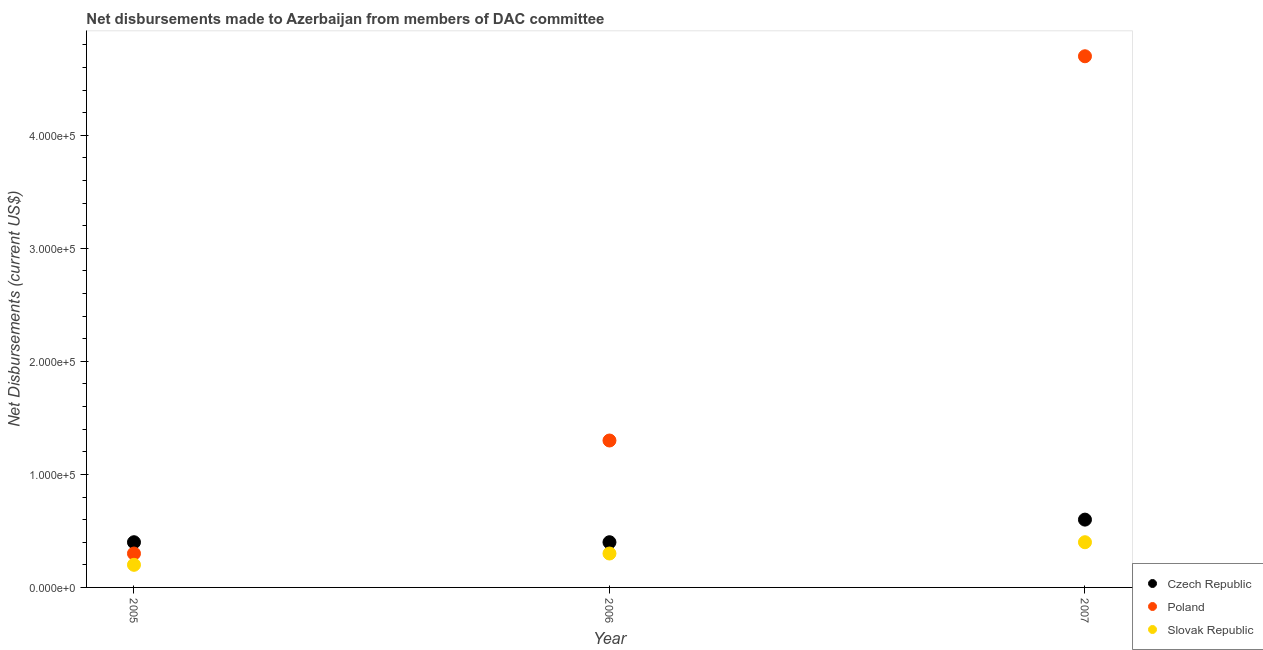What is the net disbursements made by czech republic in 2007?
Provide a short and direct response. 6.00e+04. Across all years, what is the maximum net disbursements made by czech republic?
Your answer should be compact. 6.00e+04. Across all years, what is the minimum net disbursements made by poland?
Make the answer very short. 3.00e+04. In which year was the net disbursements made by poland maximum?
Provide a short and direct response. 2007. In which year was the net disbursements made by slovak republic minimum?
Your answer should be compact. 2005. What is the total net disbursements made by poland in the graph?
Your answer should be very brief. 6.30e+05. What is the difference between the net disbursements made by czech republic in 2006 and that in 2007?
Keep it short and to the point. -2.00e+04. What is the difference between the net disbursements made by czech republic in 2007 and the net disbursements made by slovak republic in 2005?
Your response must be concise. 4.00e+04. What is the average net disbursements made by czech republic per year?
Make the answer very short. 4.67e+04. In the year 2005, what is the difference between the net disbursements made by slovak republic and net disbursements made by czech republic?
Your answer should be compact. -2.00e+04. What is the ratio of the net disbursements made by slovak republic in 2005 to that in 2006?
Offer a terse response. 0.67. Is the net disbursements made by czech republic in 2006 less than that in 2007?
Offer a very short reply. Yes. What is the difference between the highest and the lowest net disbursements made by poland?
Your response must be concise. 4.40e+05. Is the net disbursements made by czech republic strictly less than the net disbursements made by poland over the years?
Your answer should be very brief. No. How many years are there in the graph?
Give a very brief answer. 3. Does the graph contain any zero values?
Provide a succinct answer. No. Does the graph contain grids?
Give a very brief answer. No. How many legend labels are there?
Give a very brief answer. 3. What is the title of the graph?
Ensure brevity in your answer.  Net disbursements made to Azerbaijan from members of DAC committee. What is the label or title of the X-axis?
Make the answer very short. Year. What is the label or title of the Y-axis?
Your answer should be compact. Net Disbursements (current US$). What is the Net Disbursements (current US$) in Poland in 2005?
Provide a succinct answer. 3.00e+04. What is the Net Disbursements (current US$) in Slovak Republic in 2005?
Your answer should be very brief. 2.00e+04. What is the Net Disbursements (current US$) of Czech Republic in 2006?
Your answer should be very brief. 4.00e+04. What is the Net Disbursements (current US$) of Poland in 2006?
Your answer should be compact. 1.30e+05. What is the Net Disbursements (current US$) of Poland in 2007?
Give a very brief answer. 4.70e+05. Across all years, what is the minimum Net Disbursements (current US$) of Czech Republic?
Offer a terse response. 4.00e+04. Across all years, what is the minimum Net Disbursements (current US$) in Poland?
Offer a terse response. 3.00e+04. What is the total Net Disbursements (current US$) in Czech Republic in the graph?
Your answer should be compact. 1.40e+05. What is the total Net Disbursements (current US$) of Poland in the graph?
Give a very brief answer. 6.30e+05. What is the difference between the Net Disbursements (current US$) in Poland in 2005 and that in 2006?
Provide a succinct answer. -1.00e+05. What is the difference between the Net Disbursements (current US$) in Poland in 2005 and that in 2007?
Make the answer very short. -4.40e+05. What is the difference between the Net Disbursements (current US$) of Czech Republic in 2006 and that in 2007?
Offer a terse response. -2.00e+04. What is the difference between the Net Disbursements (current US$) in Poland in 2006 and that in 2007?
Your answer should be very brief. -3.40e+05. What is the difference between the Net Disbursements (current US$) in Slovak Republic in 2006 and that in 2007?
Your answer should be compact. -10000. What is the difference between the Net Disbursements (current US$) of Czech Republic in 2005 and the Net Disbursements (current US$) of Poland in 2006?
Make the answer very short. -9.00e+04. What is the difference between the Net Disbursements (current US$) in Czech Republic in 2005 and the Net Disbursements (current US$) in Slovak Republic in 2006?
Your answer should be compact. 10000. What is the difference between the Net Disbursements (current US$) of Czech Republic in 2005 and the Net Disbursements (current US$) of Poland in 2007?
Your answer should be compact. -4.30e+05. What is the difference between the Net Disbursements (current US$) in Poland in 2005 and the Net Disbursements (current US$) in Slovak Republic in 2007?
Your answer should be very brief. -10000. What is the difference between the Net Disbursements (current US$) of Czech Republic in 2006 and the Net Disbursements (current US$) of Poland in 2007?
Your answer should be compact. -4.30e+05. What is the difference between the Net Disbursements (current US$) of Czech Republic in 2006 and the Net Disbursements (current US$) of Slovak Republic in 2007?
Offer a terse response. 0. What is the difference between the Net Disbursements (current US$) of Poland in 2006 and the Net Disbursements (current US$) of Slovak Republic in 2007?
Ensure brevity in your answer.  9.00e+04. What is the average Net Disbursements (current US$) in Czech Republic per year?
Ensure brevity in your answer.  4.67e+04. In the year 2005, what is the difference between the Net Disbursements (current US$) of Czech Republic and Net Disbursements (current US$) of Slovak Republic?
Make the answer very short. 2.00e+04. In the year 2007, what is the difference between the Net Disbursements (current US$) in Czech Republic and Net Disbursements (current US$) in Poland?
Your response must be concise. -4.10e+05. What is the ratio of the Net Disbursements (current US$) of Czech Republic in 2005 to that in 2006?
Provide a short and direct response. 1. What is the ratio of the Net Disbursements (current US$) in Poland in 2005 to that in 2006?
Your answer should be very brief. 0.23. What is the ratio of the Net Disbursements (current US$) in Czech Republic in 2005 to that in 2007?
Your response must be concise. 0.67. What is the ratio of the Net Disbursements (current US$) of Poland in 2005 to that in 2007?
Ensure brevity in your answer.  0.06. What is the ratio of the Net Disbursements (current US$) in Poland in 2006 to that in 2007?
Keep it short and to the point. 0.28. What is the difference between the highest and the lowest Net Disbursements (current US$) in Czech Republic?
Your answer should be very brief. 2.00e+04. 